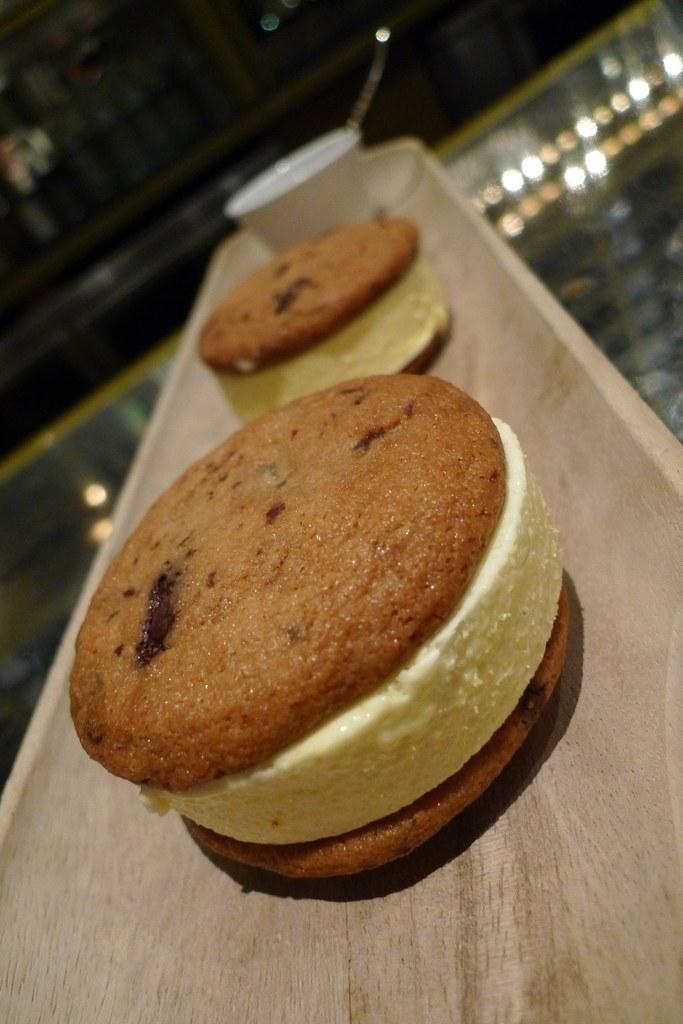What types of food items can be seen in the image? There are food items in the image, but their specific types cannot be determined from the provided facts. Where is the bowl located in the image? The bowl is on a surface in the image. What can be seen illuminating the scene in the image? There are lights visible in the image. How many pins are attached to the ticket in the image? There is no ticket or pin present in the image. What is the value of the item being sold in the image? The image does not depict any items being sold, nor does it provide information about their value. 